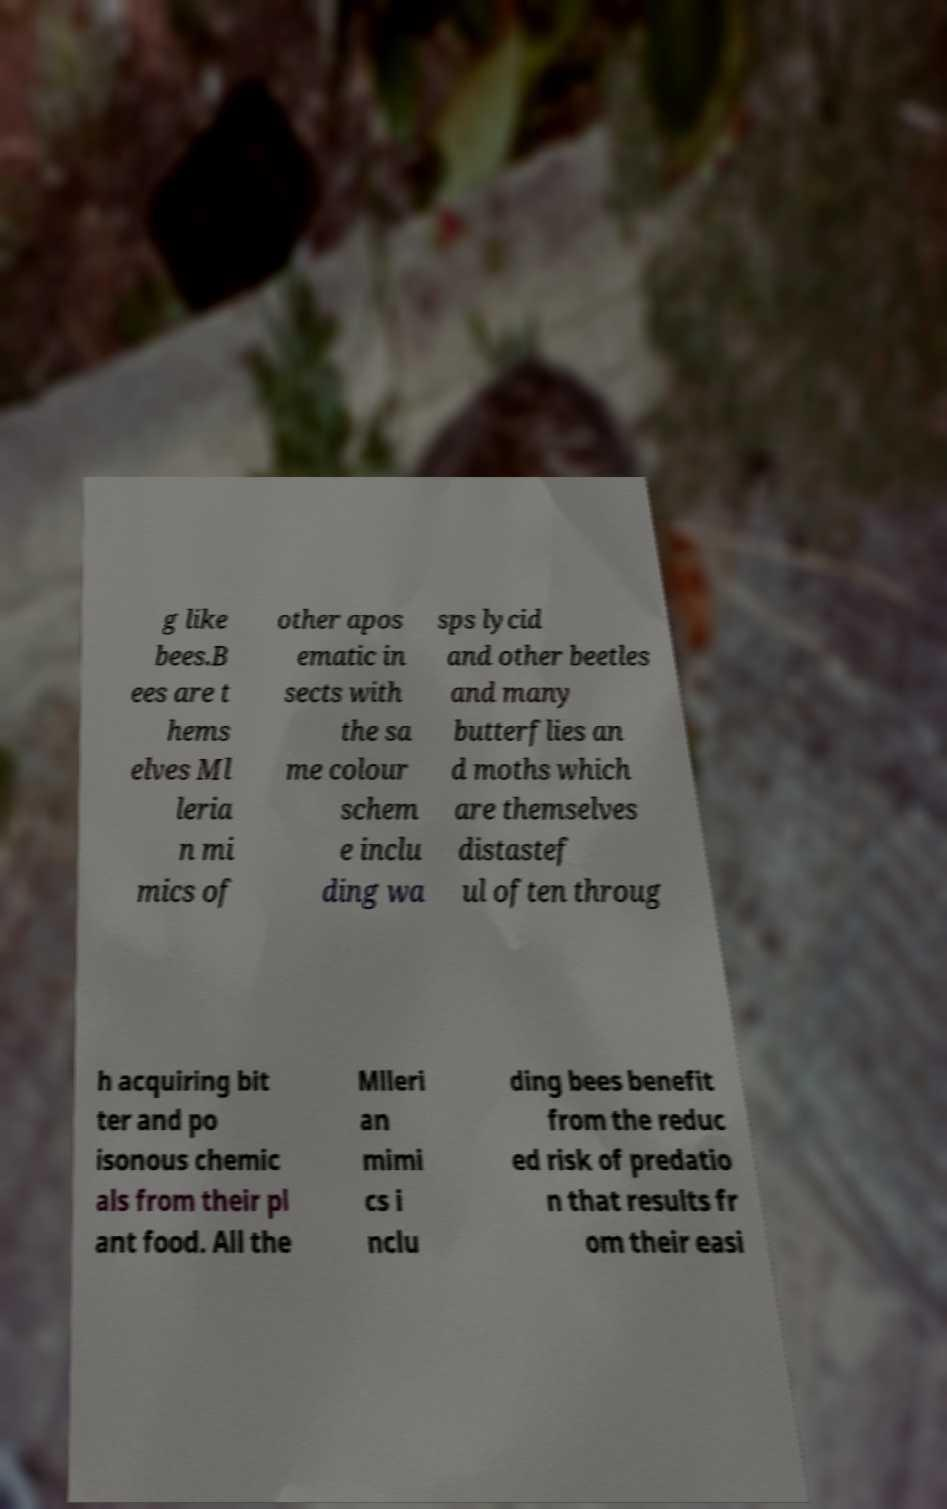There's text embedded in this image that I need extracted. Can you transcribe it verbatim? g like bees.B ees are t hems elves Ml leria n mi mics of other apos ematic in sects with the sa me colour schem e inclu ding wa sps lycid and other beetles and many butterflies an d moths which are themselves distastef ul often throug h acquiring bit ter and po isonous chemic als from their pl ant food. All the Mlleri an mimi cs i nclu ding bees benefit from the reduc ed risk of predatio n that results fr om their easi 